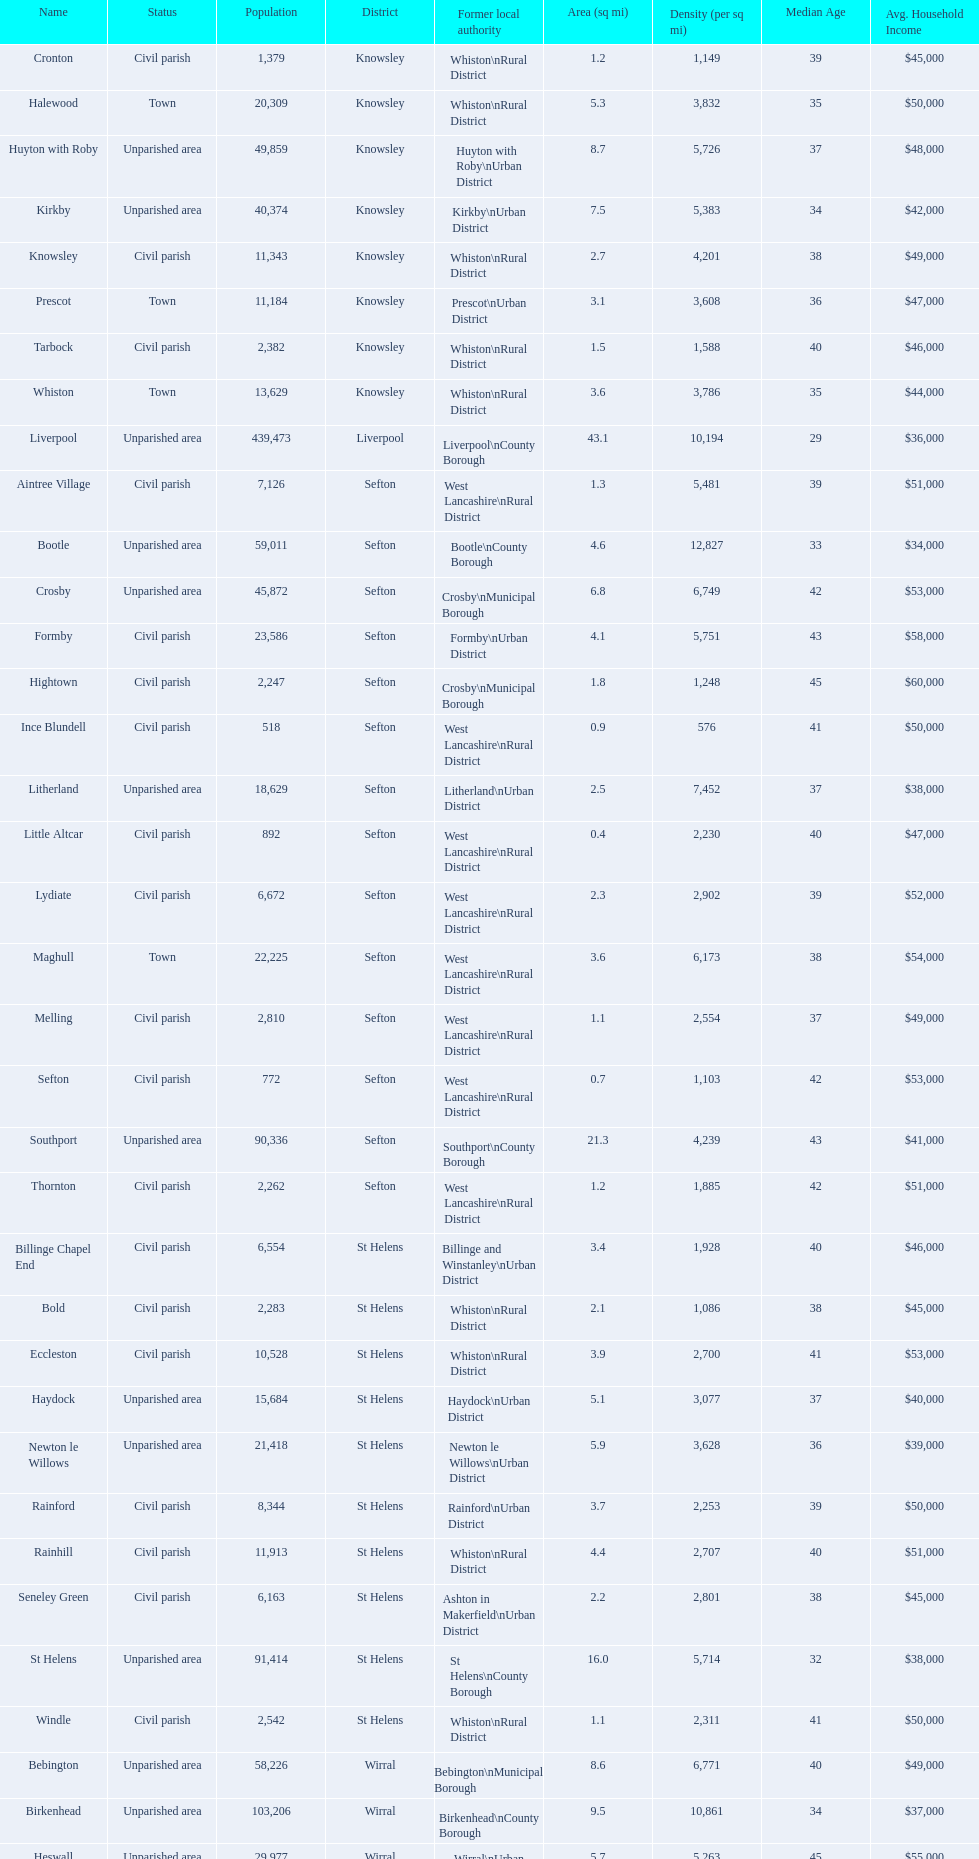How many civil parishes have population counts of at least 10,000? 4. 